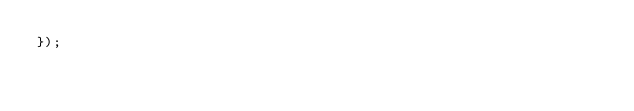<code> <loc_0><loc_0><loc_500><loc_500><_JavaScript_>});
</code> 